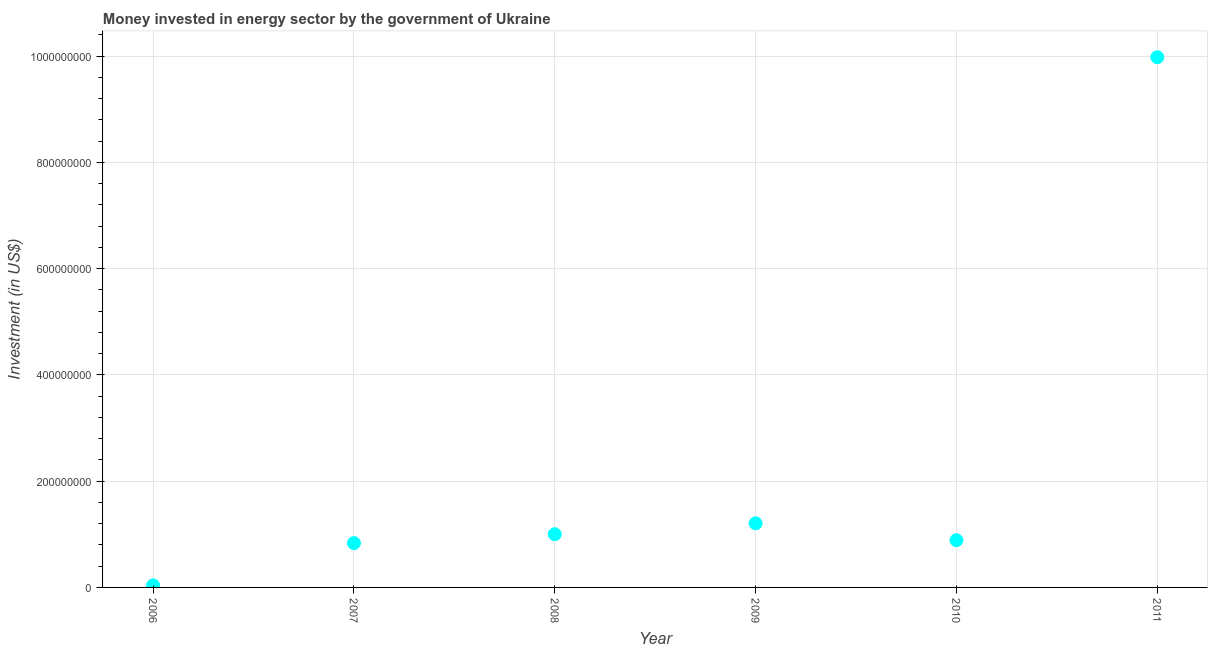What is the investment in energy in 2011?
Offer a terse response. 9.98e+08. Across all years, what is the maximum investment in energy?
Offer a very short reply. 9.98e+08. Across all years, what is the minimum investment in energy?
Give a very brief answer. 3.90e+06. In which year was the investment in energy minimum?
Make the answer very short. 2006. What is the sum of the investment in energy?
Provide a succinct answer. 1.39e+09. What is the difference between the investment in energy in 2007 and 2011?
Give a very brief answer. -9.14e+08. What is the average investment in energy per year?
Give a very brief answer. 2.32e+08. What is the median investment in energy?
Provide a succinct answer. 9.45e+07. Do a majority of the years between 2007 and 2008 (inclusive) have investment in energy greater than 480000000 US$?
Offer a terse response. No. What is the ratio of the investment in energy in 2006 to that in 2011?
Offer a terse response. 0. Is the difference between the investment in energy in 2008 and 2011 greater than the difference between any two years?
Provide a short and direct response. No. What is the difference between the highest and the second highest investment in energy?
Offer a terse response. 8.77e+08. What is the difference between the highest and the lowest investment in energy?
Provide a succinct answer. 9.94e+08. In how many years, is the investment in energy greater than the average investment in energy taken over all years?
Keep it short and to the point. 1. Does the investment in energy monotonically increase over the years?
Provide a short and direct response. No. How many dotlines are there?
Your answer should be very brief. 1. How many years are there in the graph?
Your response must be concise. 6. What is the difference between two consecutive major ticks on the Y-axis?
Offer a very short reply. 2.00e+08. Are the values on the major ticks of Y-axis written in scientific E-notation?
Offer a very short reply. No. What is the title of the graph?
Provide a short and direct response. Money invested in energy sector by the government of Ukraine. What is the label or title of the Y-axis?
Provide a short and direct response. Investment (in US$). What is the Investment (in US$) in 2006?
Offer a terse response. 3.90e+06. What is the Investment (in US$) in 2007?
Your response must be concise. 8.34e+07. What is the Investment (in US$) in 2008?
Provide a succinct answer. 1.00e+08. What is the Investment (in US$) in 2009?
Offer a very short reply. 1.21e+08. What is the Investment (in US$) in 2010?
Offer a very short reply. 8.89e+07. What is the Investment (in US$) in 2011?
Offer a terse response. 9.98e+08. What is the difference between the Investment (in US$) in 2006 and 2007?
Provide a succinct answer. -7.95e+07. What is the difference between the Investment (in US$) in 2006 and 2008?
Provide a short and direct response. -9.62e+07. What is the difference between the Investment (in US$) in 2006 and 2009?
Make the answer very short. -1.17e+08. What is the difference between the Investment (in US$) in 2006 and 2010?
Give a very brief answer. -8.50e+07. What is the difference between the Investment (in US$) in 2006 and 2011?
Give a very brief answer. -9.94e+08. What is the difference between the Investment (in US$) in 2007 and 2008?
Your answer should be compact. -1.67e+07. What is the difference between the Investment (in US$) in 2007 and 2009?
Your response must be concise. -3.73e+07. What is the difference between the Investment (in US$) in 2007 and 2010?
Give a very brief answer. -5.51e+06. What is the difference between the Investment (in US$) in 2007 and 2011?
Offer a very short reply. -9.14e+08. What is the difference between the Investment (in US$) in 2008 and 2009?
Your answer should be compact. -2.06e+07. What is the difference between the Investment (in US$) in 2008 and 2010?
Keep it short and to the point. 1.12e+07. What is the difference between the Investment (in US$) in 2008 and 2011?
Give a very brief answer. -8.98e+08. What is the difference between the Investment (in US$) in 2009 and 2010?
Ensure brevity in your answer.  3.18e+07. What is the difference between the Investment (in US$) in 2009 and 2011?
Provide a short and direct response. -8.77e+08. What is the difference between the Investment (in US$) in 2010 and 2011?
Your response must be concise. -9.09e+08. What is the ratio of the Investment (in US$) in 2006 to that in 2007?
Keep it short and to the point. 0.05. What is the ratio of the Investment (in US$) in 2006 to that in 2008?
Provide a short and direct response. 0.04. What is the ratio of the Investment (in US$) in 2006 to that in 2009?
Ensure brevity in your answer.  0.03. What is the ratio of the Investment (in US$) in 2006 to that in 2010?
Provide a short and direct response. 0.04. What is the ratio of the Investment (in US$) in 2006 to that in 2011?
Ensure brevity in your answer.  0. What is the ratio of the Investment (in US$) in 2007 to that in 2008?
Offer a terse response. 0.83. What is the ratio of the Investment (in US$) in 2007 to that in 2009?
Your response must be concise. 0.69. What is the ratio of the Investment (in US$) in 2007 to that in 2010?
Offer a terse response. 0.94. What is the ratio of the Investment (in US$) in 2007 to that in 2011?
Offer a very short reply. 0.08. What is the ratio of the Investment (in US$) in 2008 to that in 2009?
Keep it short and to the point. 0.83. What is the ratio of the Investment (in US$) in 2008 to that in 2010?
Offer a very short reply. 1.13. What is the ratio of the Investment (in US$) in 2009 to that in 2010?
Offer a terse response. 1.36. What is the ratio of the Investment (in US$) in 2009 to that in 2011?
Keep it short and to the point. 0.12. What is the ratio of the Investment (in US$) in 2010 to that in 2011?
Ensure brevity in your answer.  0.09. 